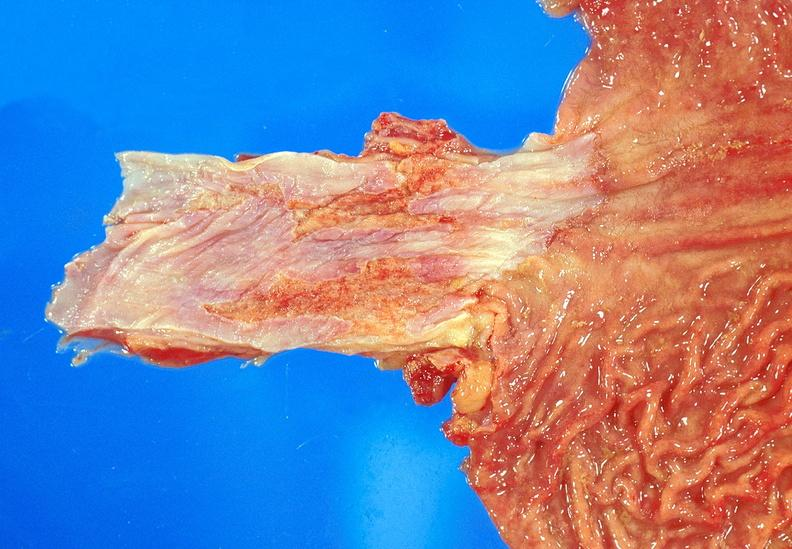what is present?
Answer the question using a single word or phrase. Gastrointestinal 